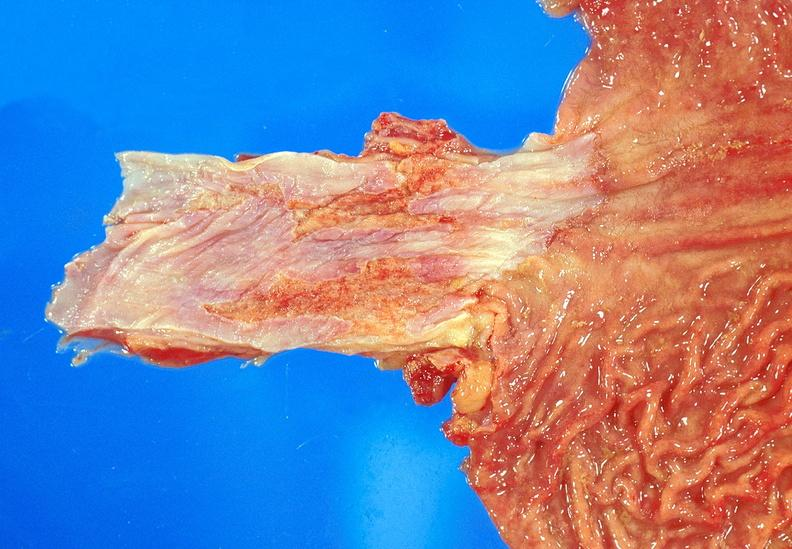what is present?
Answer the question using a single word or phrase. Gastrointestinal 